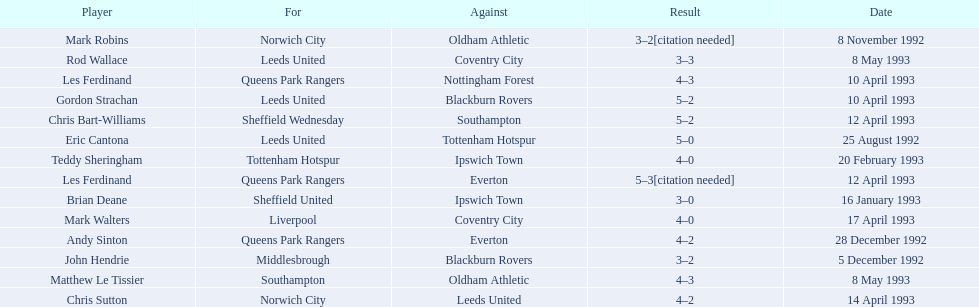Who does john hendrie play for? Middlesbrough. 